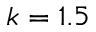Convert formula to latex. <formula><loc_0><loc_0><loc_500><loc_500>k = 1 . 5</formula> 